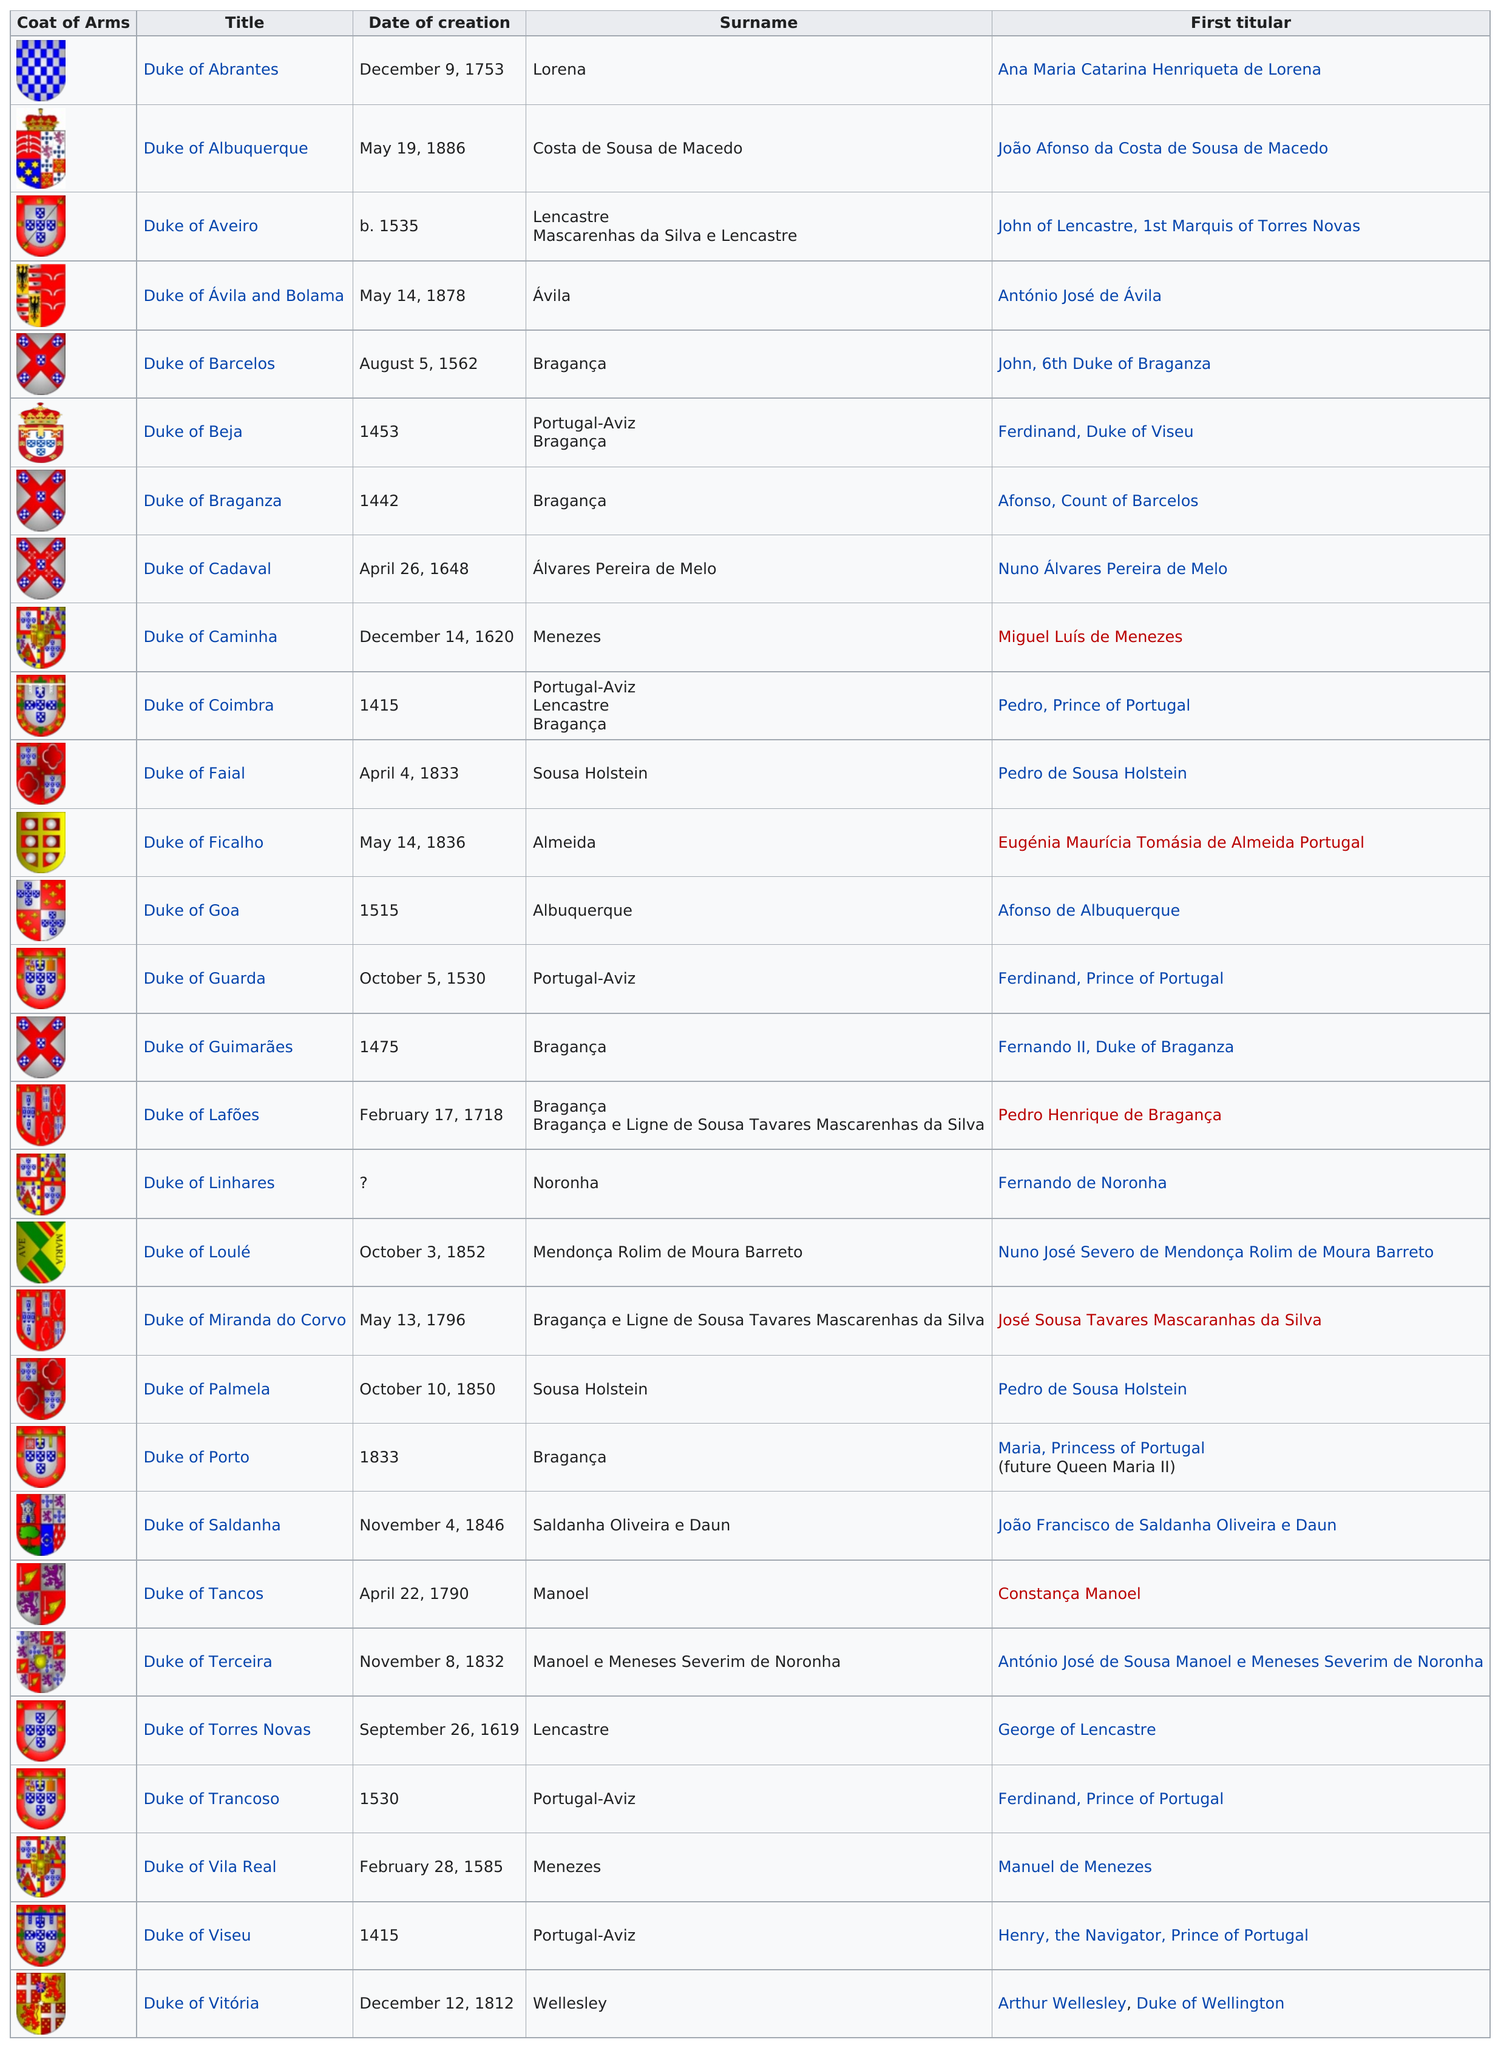Mention a couple of crucial points in this snapshot. There are 29 dukedoms in Portugal. Ávila is listed before Bragança in the list. There were a total of 11 dukedoms created before the year 1600. The Duke of Abrantes was the only duke who did not have red in their coat of arms. After the Duke of Barcelos, the next dukedom to be created was the Duke of Ávila and Bolama. 